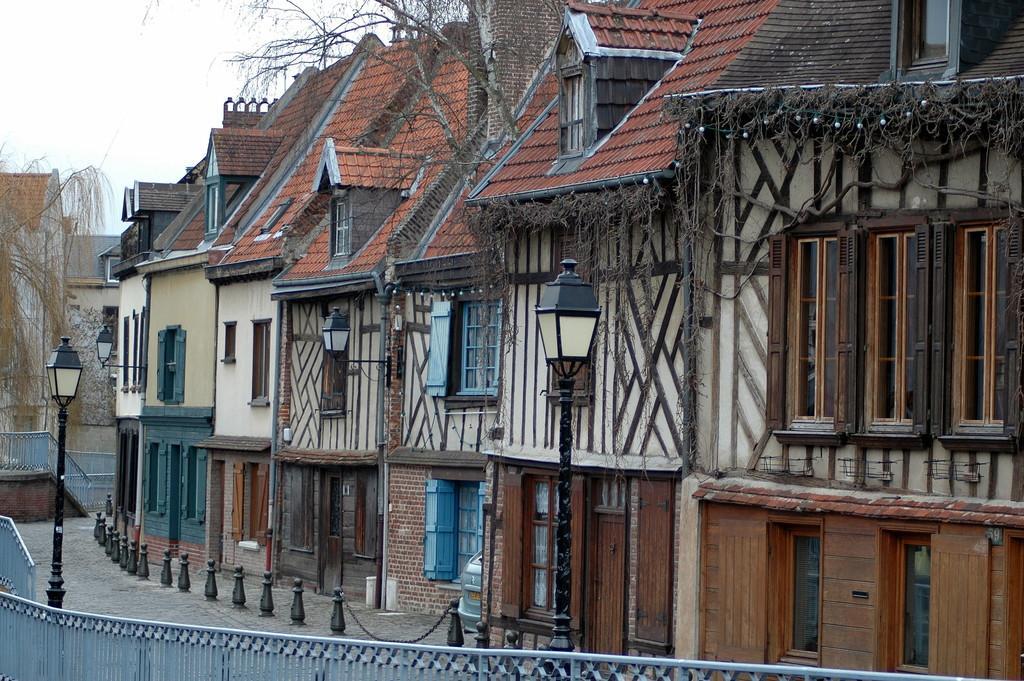In one or two sentences, can you explain what this image depicts? In this picture I can see the buildings. I can see pole lights. I can see the metal grill fence. I can see clouds in the sky. 